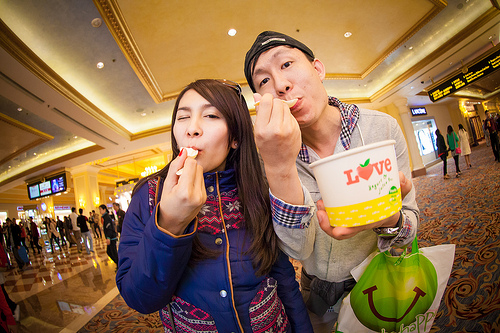<image>
Is the woman behind the man? No. The woman is not behind the man. From this viewpoint, the woman appears to be positioned elsewhere in the scene. Is there a girl to the right of the boy? Yes. From this viewpoint, the girl is positioned to the right side relative to the boy. 